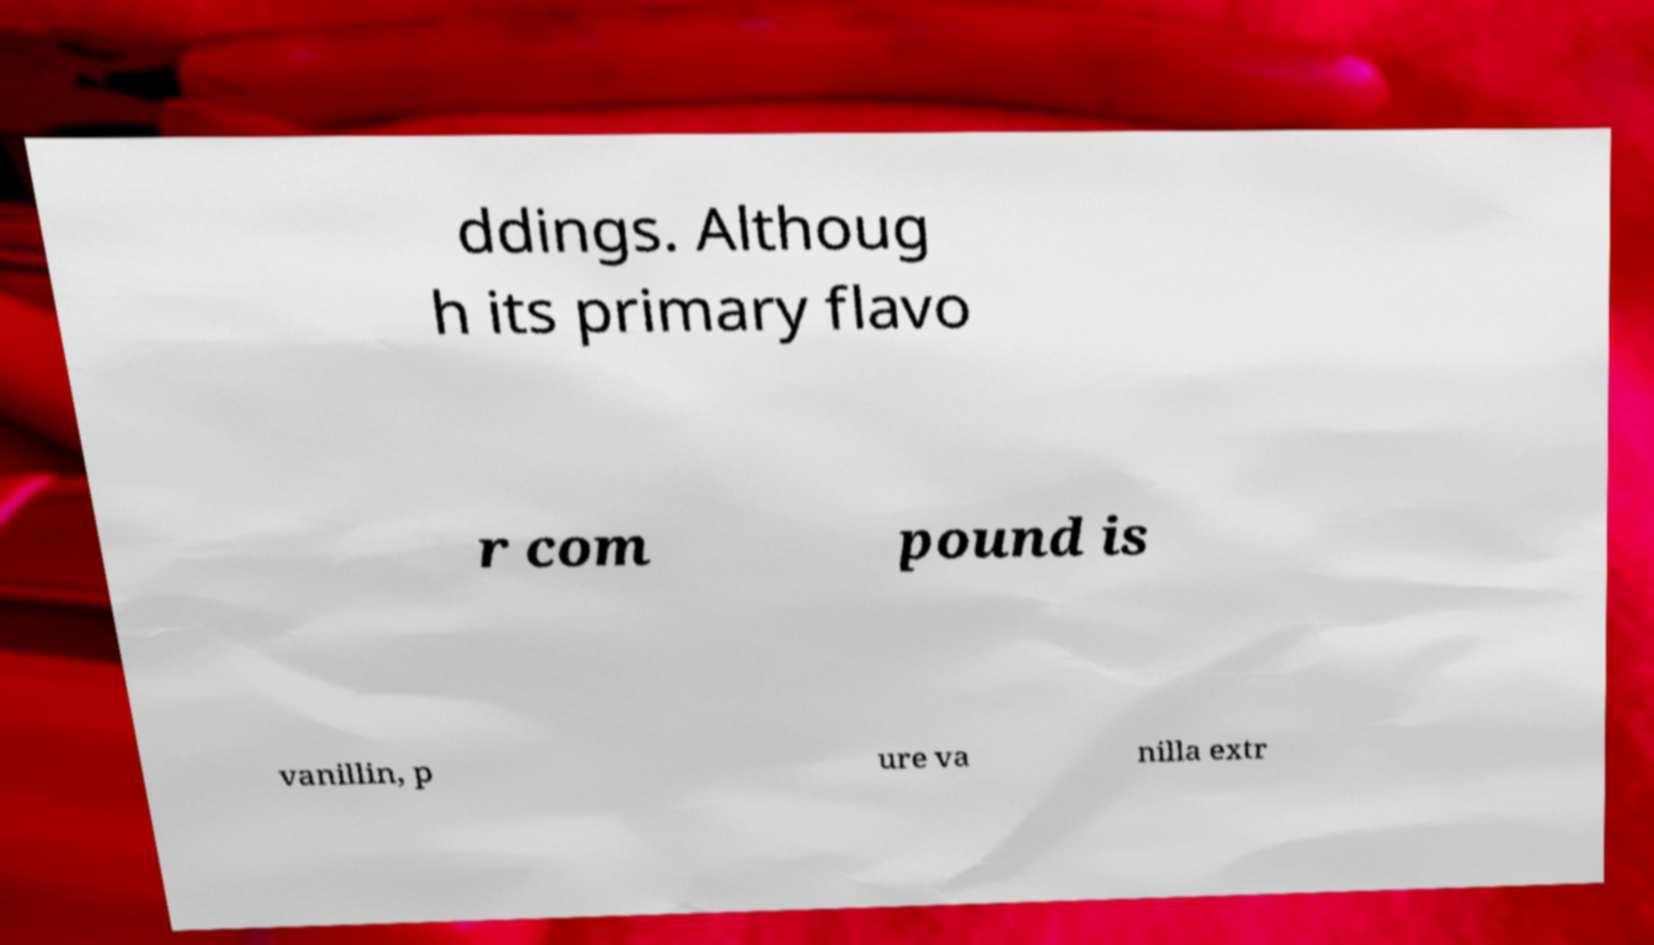Please identify and transcribe the text found in this image. ddings. Althoug h its primary flavo r com pound is vanillin, p ure va nilla extr 